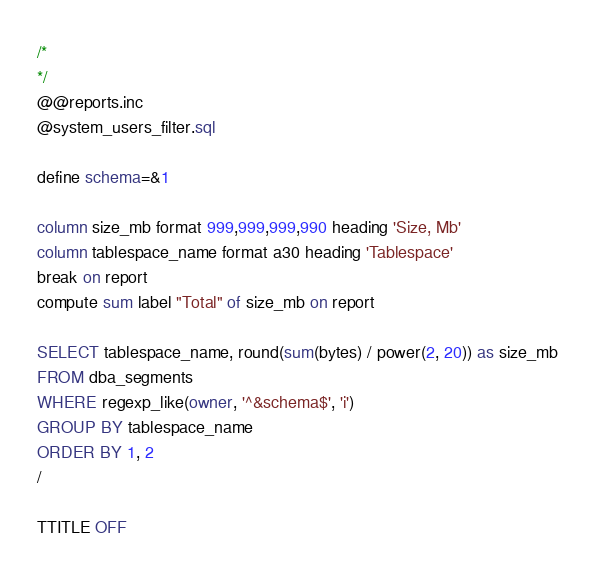<code> <loc_0><loc_0><loc_500><loc_500><_SQL_>/*
*/
@@reports.inc
@system_users_filter.sql

define schema=&1

column size_mb format 999,999,999,990 heading 'Size, Mb'
column tablespace_name format a30 heading 'Tablespace'
break on report
compute sum label "Total" of size_mb on report

SELECT tablespace_name, round(sum(bytes) / power(2, 20)) as size_mb
FROM dba_segments
WHERE regexp_like(owner, '^&schema$', 'i')
GROUP BY tablespace_name
ORDER BY 1, 2
/

TTITLE OFF
</code> 